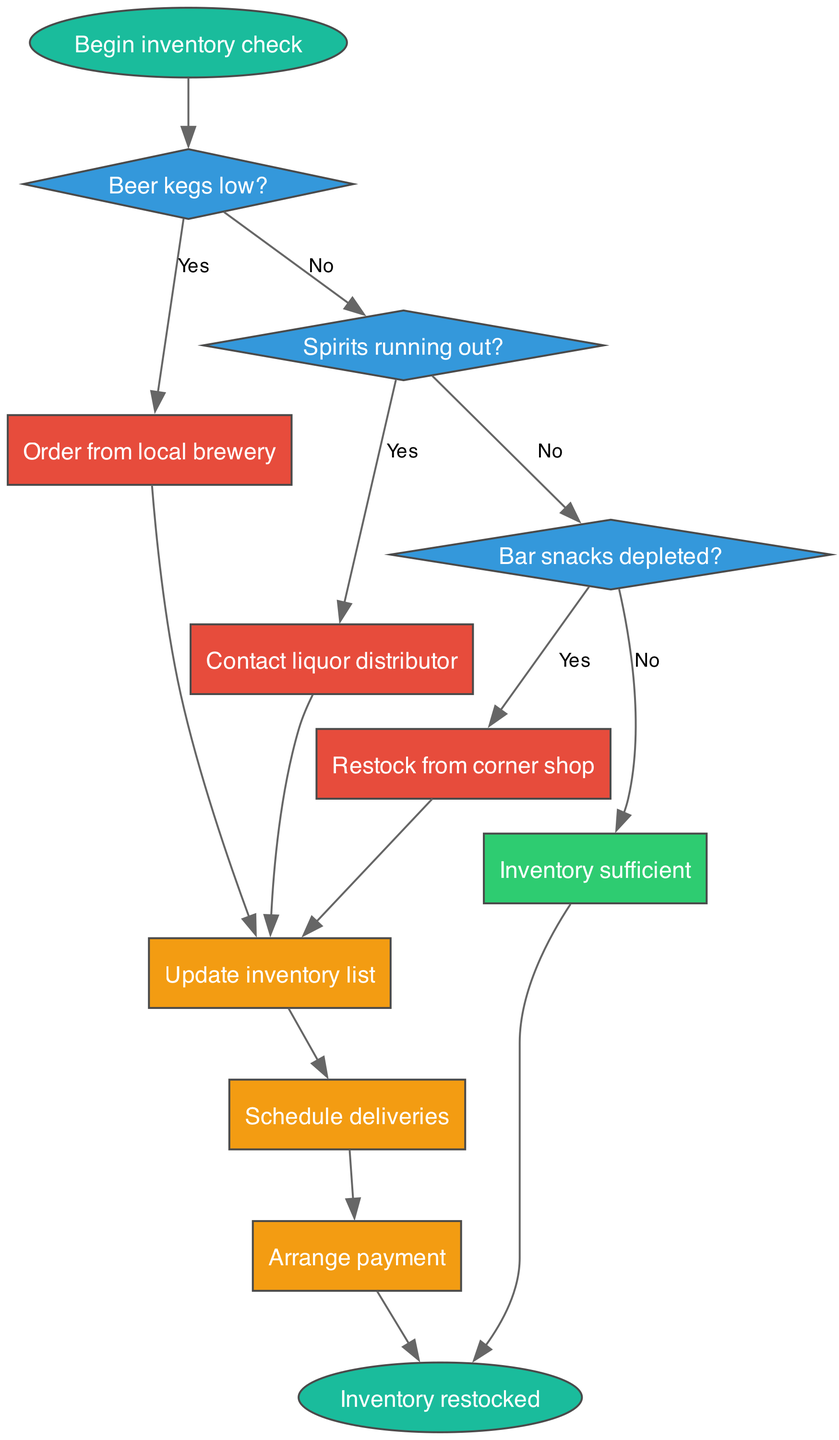What is the starting point of the flowchart? The starting point of the flowchart is labeled "Begin inventory check," which initiates the process. This can be found as the first node in the flowchart.
Answer: Begin inventory check How many decision points are present in the flowchart? There are three decision points in the flowchart, which are represented by the diamond-shaped nodes asking about the status of beer kegs, spirits, and bar snacks.
Answer: 3 What is the action taken if beer kegs are low? If beer kegs are low, the action taken is to "Order from local brewery," which is indicated by the corresponding node linked to the first decision point.
Answer: Order from local brewery What happens if bar snacks are not depleted? If bar snacks are not depleted, the flowchart indicates that the inventory is considered sufficient, and it leads directly to the end node. This connection is labeled as "No" from the bar snacks decision point.
Answer: Inventory sufficient What is the last process listed in the flowchart? The last process listed in the flowchart is "Arrange payment," which is the final action taken after restocking inventory, preceding the end of the process.
Answer: Arrange payment If spirits are running out, what is the next action? If spirits are running out, the next action is to "Contact liquor distributor," which follows directly after the second decision node when the answer to the spirits question is "Yes."
Answer: Contact liquor distributor Which node leads to the end of the flowchart? The end of the flowchart is reached either from the node labeled "Inventory sufficient," indicating that nothing needs to be restocked, or from the last process node after "Arrange payment," both of which direct to the end node.
Answer: Inventory sufficient and Arrange payment What color represents the decision nodes in the flowchart? The decision nodes in the flowchart are represented in a blue color, specifically using the hex code associated with the fillcolor for the diamond shapes.
Answer: Blue 